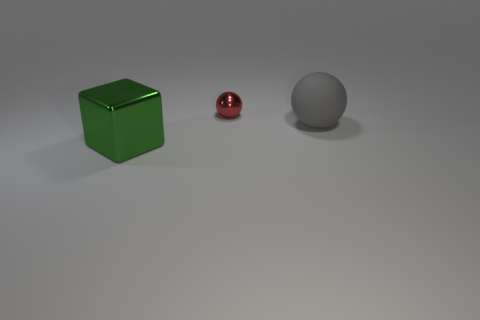Subtract all red balls. How many balls are left? 1 Add 3 big blue metallic cubes. How many objects exist? 6 Subtract 1 cubes. How many cubes are left? 0 Subtract all balls. How many objects are left? 1 Subtract all tiny cubes. Subtract all balls. How many objects are left? 1 Add 1 tiny spheres. How many tiny spheres are left? 2 Add 1 green things. How many green things exist? 2 Subtract 0 brown cylinders. How many objects are left? 3 Subtract all yellow blocks. Subtract all blue cylinders. How many blocks are left? 1 Subtract all purple balls. How many purple blocks are left? 0 